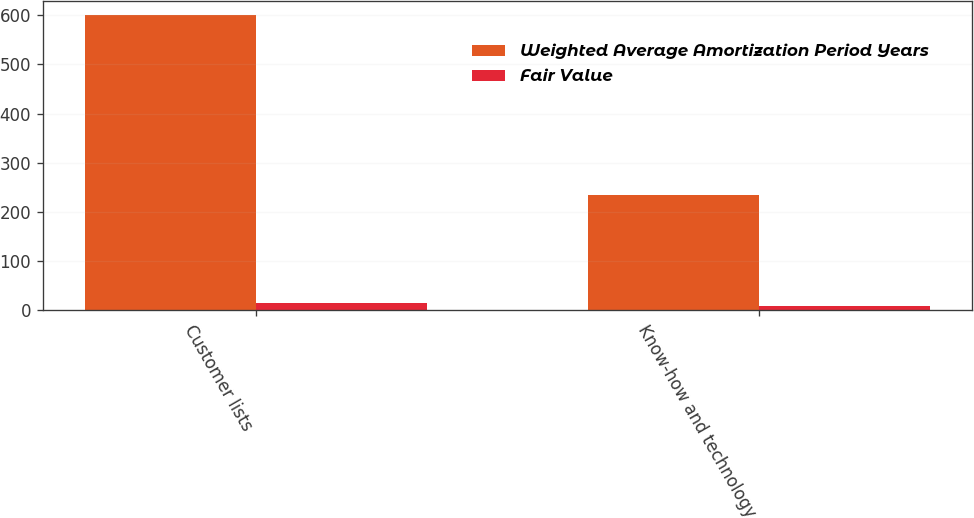Convert chart to OTSL. <chart><loc_0><loc_0><loc_500><loc_500><stacked_bar_chart><ecel><fcel>Customer lists<fcel>Know-how and technology<nl><fcel>Weighted Average Amortization Period Years<fcel>600<fcel>235<nl><fcel>Fair Value<fcel>15<fcel>9<nl></chart> 